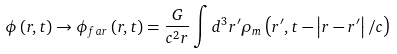<formula> <loc_0><loc_0><loc_500><loc_500>\phi \left ( { { r } , t } \right ) \to \phi _ { f a r } \left ( { { r } , t } \right ) = \frac { G } { c ^ { 2 } r } \int { d ^ { 3 } { r ^ { \prime } } } \rho _ { m } \left ( { { r ^ { \prime } } , t - \left | { { r } - { r ^ { \prime } } } \right | / c } \right )</formula> 